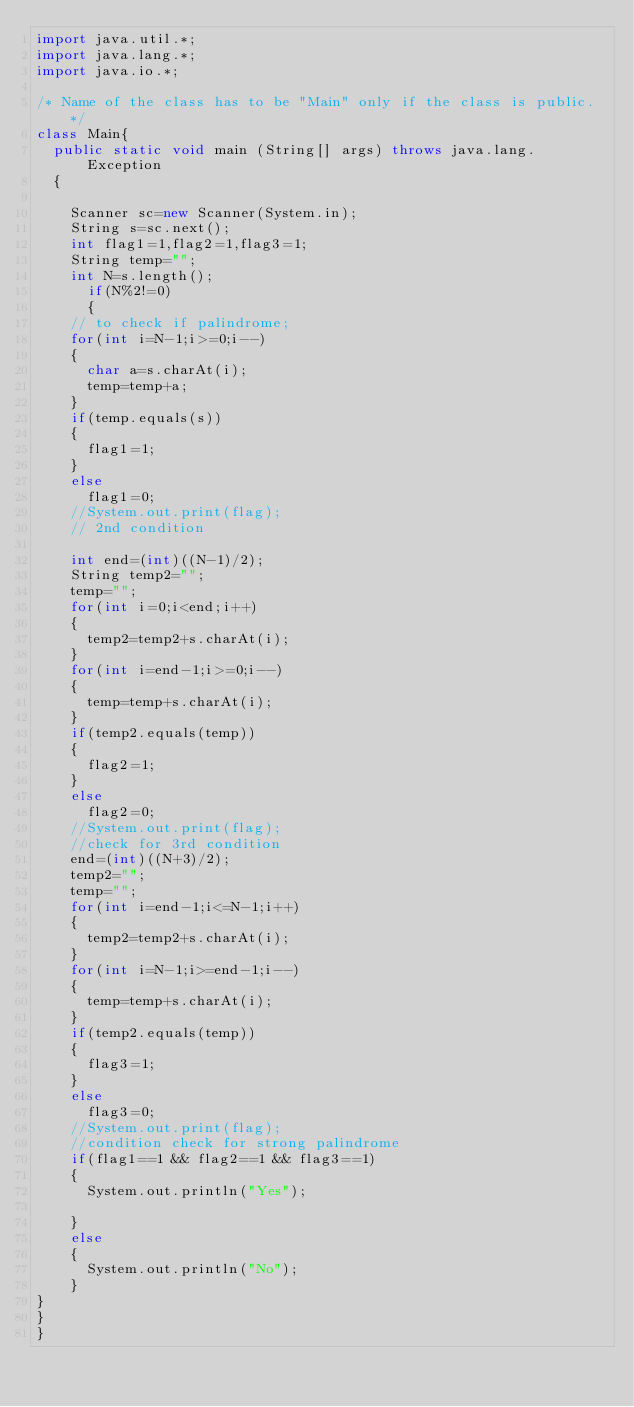<code> <loc_0><loc_0><loc_500><loc_500><_Java_>import java.util.*;
import java.lang.*;
import java.io.*;

/* Name of the class has to be "Main" only if the class is public. */
class Main{
	public static void main (String[] args) throws java.lang.Exception
	{
		
		Scanner sc=new Scanner(System.in);
		String s=sc.next();
		int flag1=1,flag2=1,flag3=1;
		String temp="";
		int N=s.length();
      if(N%2!=0)
      {
		// to check if palindrome;
		for(int i=N-1;i>=0;i--)
		{
			char a=s.charAt(i);
			temp=temp+a;
		}
		if(temp.equals(s))
		{
			flag1=1;
		}
		else
			flag1=0;
		//System.out.print(flag);
		// 2nd condition
		
		int end=(int)((N-1)/2);
		String temp2="";
		temp="";
		for(int i=0;i<end;i++)
		{
			temp2=temp2+s.charAt(i);
		}
		for(int i=end-1;i>=0;i--)
		{
			temp=temp+s.charAt(i);
		}
		if(temp2.equals(temp))
		{
			flag2=1;
		}
		else
			flag2=0;
		//System.out.print(flag);
		//check for 3rd condition
		end=(int)((N+3)/2);
		temp2="";
		temp="";
		for(int i=end-1;i<=N-1;i++)
		{
			temp2=temp2+s.charAt(i);
		}
		for(int i=N-1;i>=end-1;i--)
		{
			temp=temp+s.charAt(i);
		}
		if(temp2.equals(temp))
		{
			flag3=1;
		}
		else
			flag3=0;
		//System.out.print(flag);
		//condition check for strong palindrome
		if(flag1==1 && flag2==1 && flag3==1)
		{
			System.out.println("Yes");
			
		}
		else
		{
			System.out.println("No");
		}
}
}
}</code> 